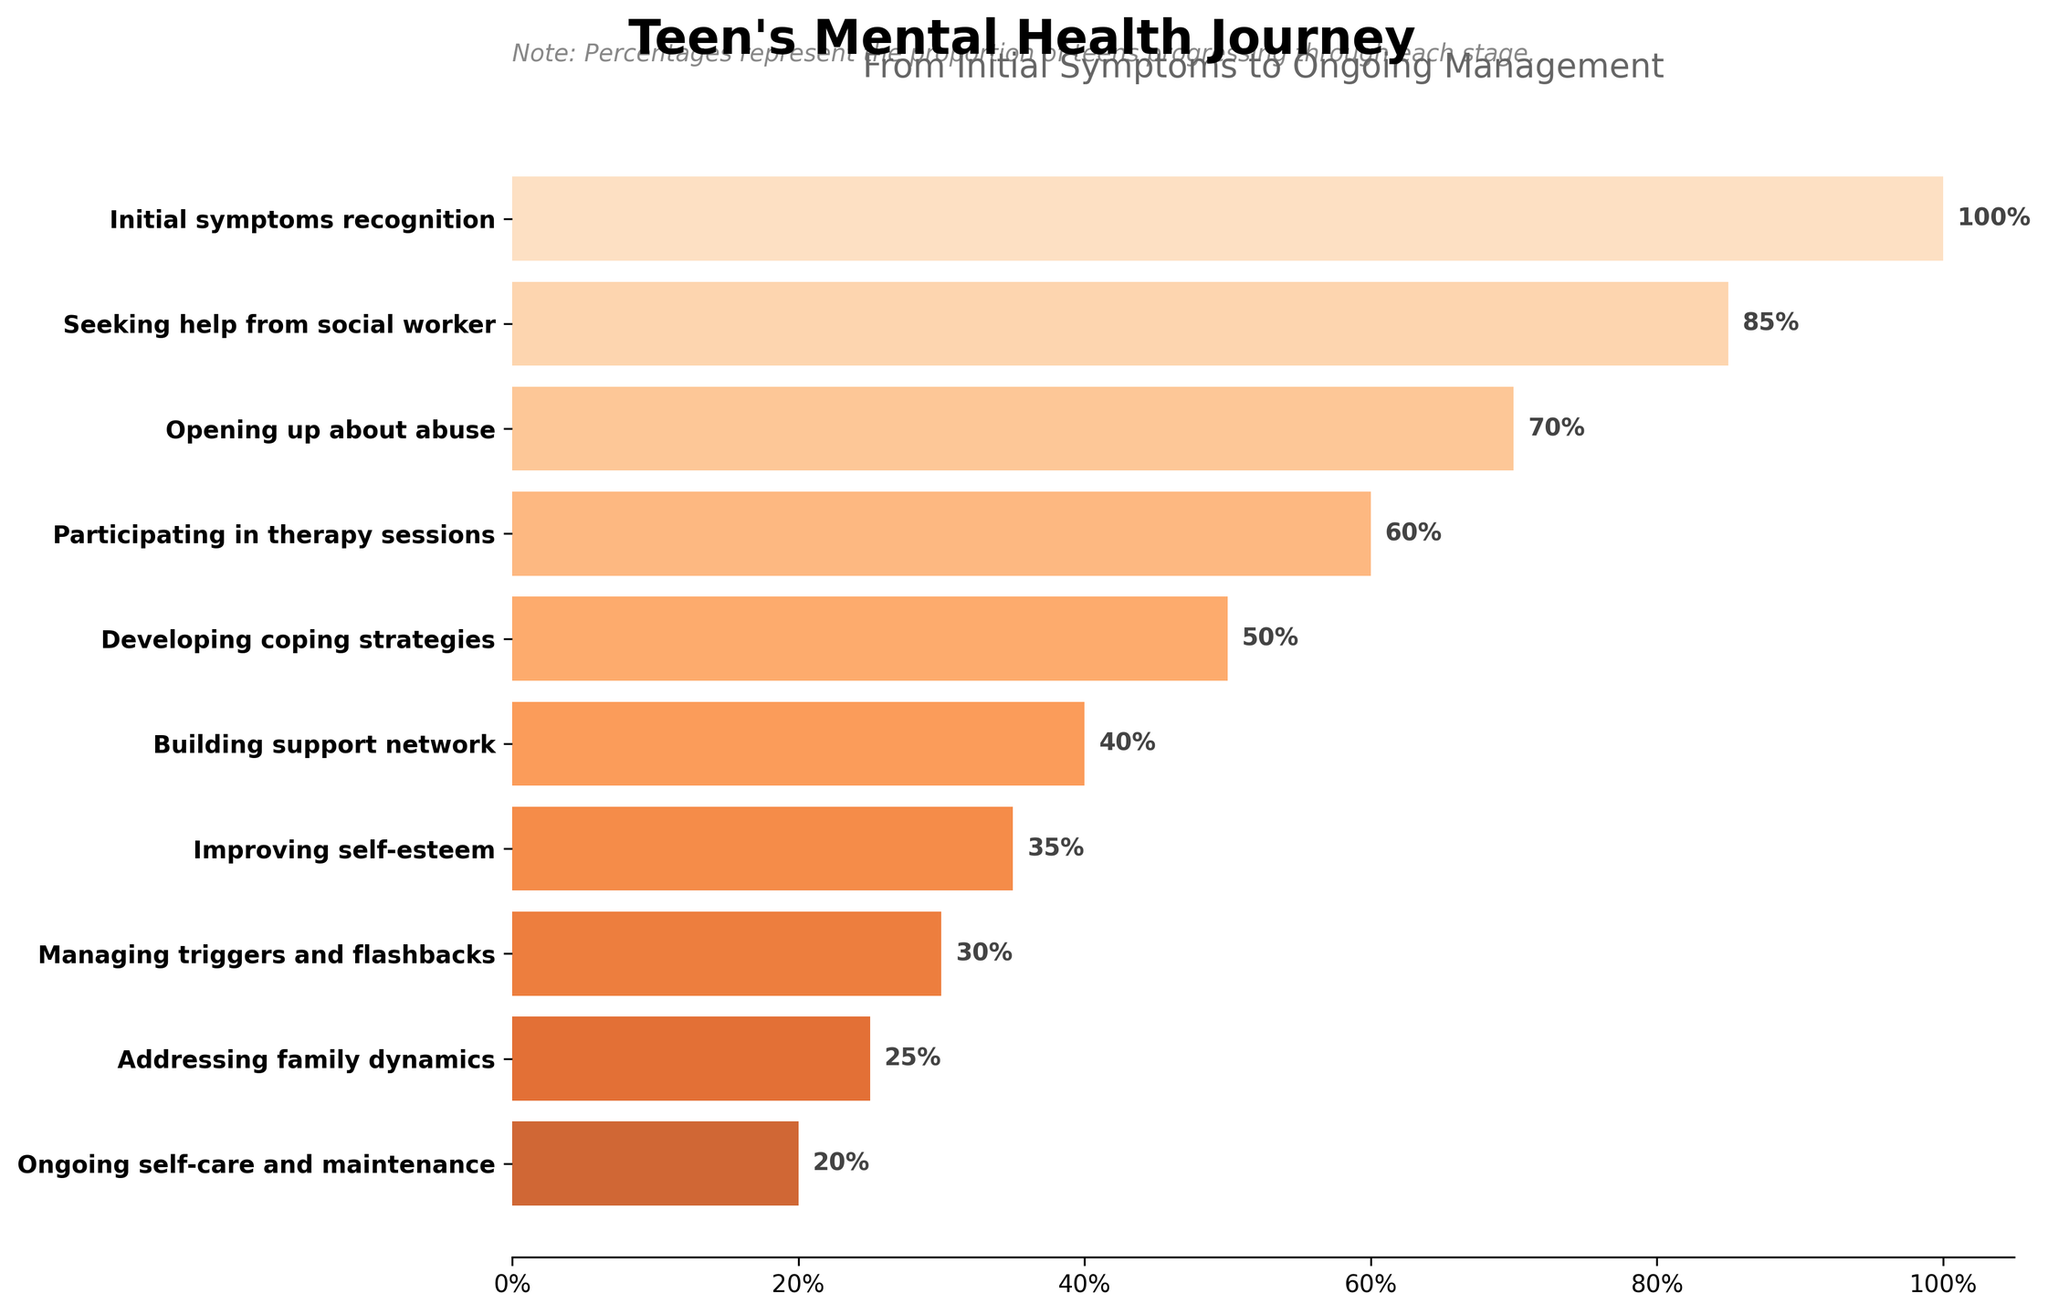what is the title of the figure? The title of the figure is mentioned at the top of the plot. It is typically distinct and bold compared to the other text elements.
Answer: Teen's Mental Health Journey What is the percentage of teenagers who seek help from a social worker? Look for the stage "Seeking help from social worker" on the y-axis and read the corresponding percentage on the x-axis.
Answer: 85% How many stages are depicted in the teenager's mental health journey? Count the number of unique stages listed on the y-axis of the chart.
Answer: 10 What stage has the lowest percentage of teenagers? Identify the stage with the smallest bar (or lowest percentage value) on the chart.
Answer: Ongoing self-care and maintenance Which stage shows a 50% progression? Find the stage on the y-axis where the bar length corresponds to the 50% mark on the x-axis.
Answer: Developing coping strategies What is the difference in percentage between teenagers opening up about abuse and participating in therapy sessions? Subtract the percentage value of "Participating in therapy sessions" from "Opening up about abuse".
Answer: 10% At which stage do half of the teenagers progress through their mental health journey? Find the stage on the y-axis where the progression percentage is closest to 50%.
Answer: Developing coping strategies Which stages have progression percentages greater than 50%? Identify and list the stages where the percentage values are more than 50% on the x-axis.
Answer: Initial symptoms recognition, Seeking help from social worker, Opening up about abuse, and Participating in therapy sessions What stages see less than a third of teenagers progressing? Find the stages on the y-axis with percentage values below 33% on the x-axis.
Answer: Improving self-esteem, Managing triggers and flashbacks, Addressing family dynamics, Ongoing self-care and maintenance How much lower is the percentage of teenagers who manage triggers and flashbacks compared to those who build their support network? Subtract the percentage value of "Managing triggers and flashbacks" from "Building support network".
Answer: 10% 